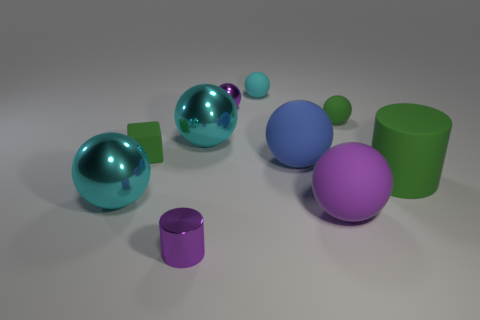Subtract all cyan balls. How many were subtracted if there are1cyan balls left? 2 Subtract all matte balls. How many balls are left? 3 Subtract all purple balls. How many balls are left? 5 Subtract all gray blocks. How many purple spheres are left? 2 Subtract all cyan blocks. Subtract all gray cylinders. How many blocks are left? 1 Subtract all balls. How many objects are left? 3 Subtract 4 balls. How many balls are left? 3 Add 6 small green cubes. How many small green cubes are left? 7 Add 5 big green metallic cylinders. How many big green metallic cylinders exist? 5 Subtract 0 brown cylinders. How many objects are left? 10 